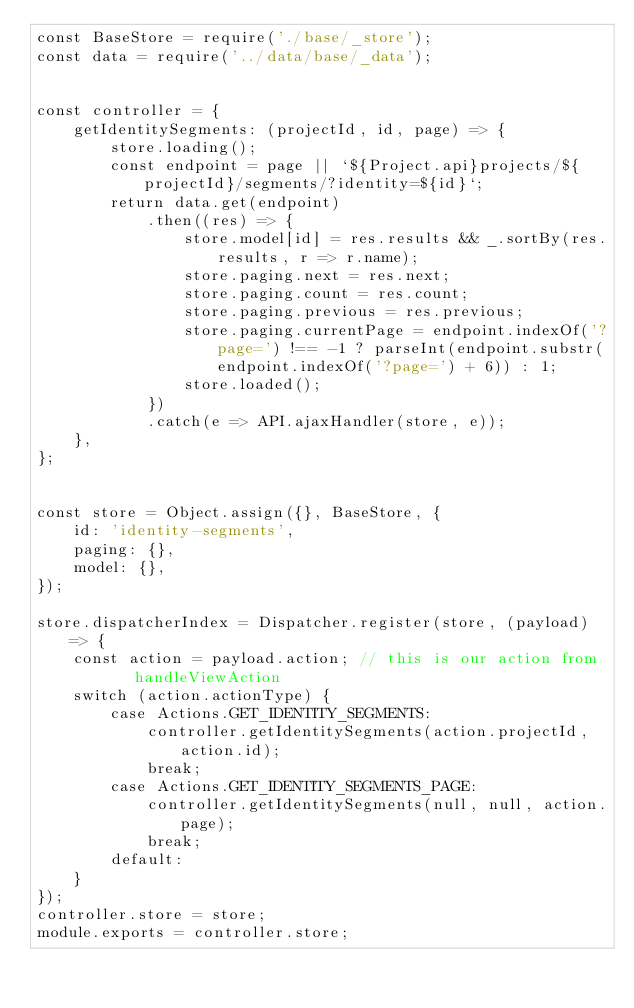<code> <loc_0><loc_0><loc_500><loc_500><_JavaScript_>const BaseStore = require('./base/_store');
const data = require('../data/base/_data');


const controller = {
    getIdentitySegments: (projectId, id, page) => {
        store.loading();
        const endpoint = page || `${Project.api}projects/${projectId}/segments/?identity=${id}`;
        return data.get(endpoint)
            .then((res) => {
                store.model[id] = res.results && _.sortBy(res.results, r => r.name);
                store.paging.next = res.next;
                store.paging.count = res.count;
                store.paging.previous = res.previous;
                store.paging.currentPage = endpoint.indexOf('?page=') !== -1 ? parseInt(endpoint.substr(endpoint.indexOf('?page=') + 6)) : 1;
                store.loaded();
            })
            .catch(e => API.ajaxHandler(store, e));
    },
};


const store = Object.assign({}, BaseStore, {
    id: 'identity-segments',
    paging: {},
    model: {},
});

store.dispatcherIndex = Dispatcher.register(store, (payload) => {
    const action = payload.action; // this is our action from	handleViewAction
    switch (action.actionType) {
        case Actions.GET_IDENTITY_SEGMENTS:
            controller.getIdentitySegments(action.projectId, action.id);
            break;
        case Actions.GET_IDENTITY_SEGMENTS_PAGE:
            controller.getIdentitySegments(null, null, action.page);
            break;
        default:
    }
});
controller.store = store;
module.exports = controller.store;
</code> 